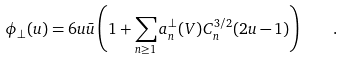Convert formula to latex. <formula><loc_0><loc_0><loc_500><loc_500>\phi _ { \perp } ( u ) = 6 u \bar { u } \left ( 1 + \sum _ { n \geq 1 } a _ { n } ^ { \perp } ( V ) C _ { n } ^ { 3 / 2 } ( 2 u - 1 ) \right ) \quad .</formula> 